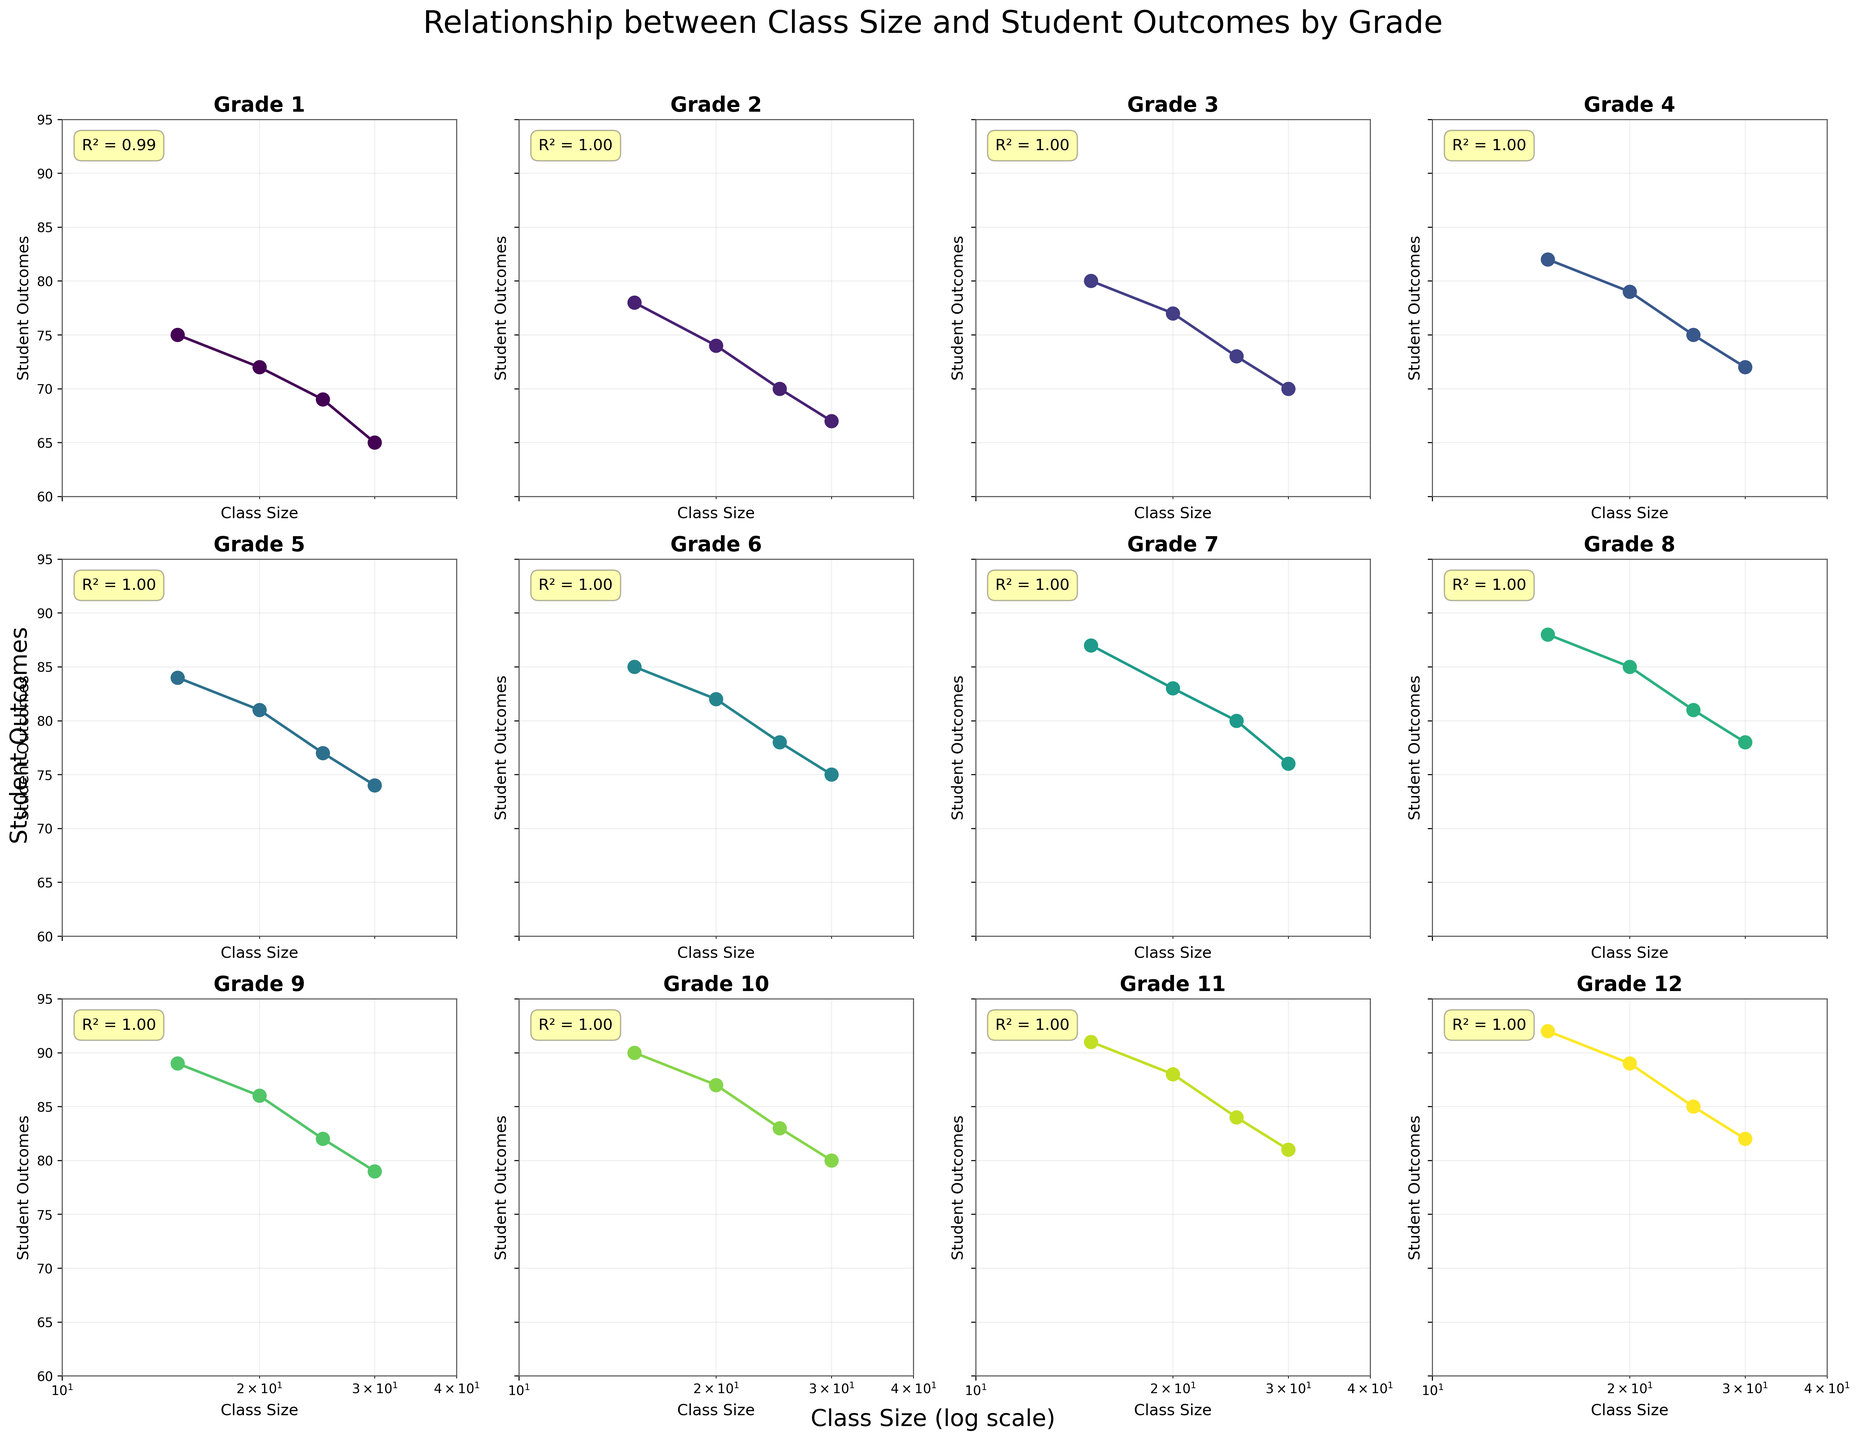What is the overall trend in student outcomes as class size increases in Grade 1? The subplot for Grade 1 shows a decrease in student outcomes with increasing class size. As class size increases from 15 to 30, student outcomes decline from 75 to 65.
Answer: Decreasing trend What is the title of the entire plot? The title is displayed at the top and reflects the relationship being studied. It reads "Relationship between Class Size and Student Outcomes by Grade".
Answer: Relationship between Class Size and Student Outcomes by Grade Which grade has the highest R² value? The subplots include an annotation box with the R² value for each grade. Grade 12 has the highest R² value, as indicated in its respective subplot.
Answer: Grade 12 What is the class size range in the plots? The x-axis of each subplot represents the class size in a log scale ranging from 10 to 40.
Answer: 10 to 40 Which grade has the lowest student outcomes for the smallest class size? Inspect each subplot for the data point corresponding to the smallest class size (15). Grade 1 has the lowest student outcome of 75 for a class size of 15.
Answer: Grade 1 In Grade 6, what are the student outcomes for class sizes 20 and 30? In Grade 6's subplot, identify the student outcomes corresponding to class sizes 20 and 30. The outcomes are 82 for class size 20 and 75 for class size 30.
Answer: 82 and 75 How do student outcomes differ between class sizes 15 and 25 in Grade 8? In Grade 8's subplot, note the student outcomes for class sizes 15 and 25, which are 88 and 81, respectively. Calculate the difference: 88 - 81 = 7.
Answer: 7 Which grade shows the least variation in student outcomes across different class sizes? Evaluate the range of student outcomes in each subplot. Grade 12 shows the least variation as outcomes range from 92 to 82.
Answer: Grade 12 For which grade does the increase in class size affect student outcomes the most negatively? Compare the differences between the student outcomes of the smallest and largest class sizes for each grade. Grade 1 shows a change from 75 to 65, the largest negative impact.
Answer: Grade 1 